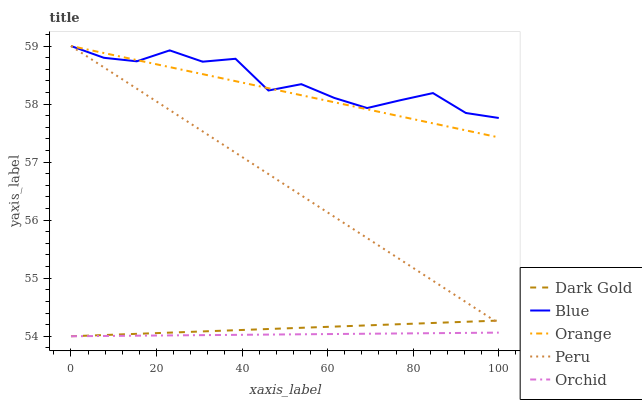Does Orchid have the minimum area under the curve?
Answer yes or no. Yes. Does Blue have the maximum area under the curve?
Answer yes or no. Yes. Does Orange have the minimum area under the curve?
Answer yes or no. No. Does Orange have the maximum area under the curve?
Answer yes or no. No. Is Peru the smoothest?
Answer yes or no. Yes. Is Blue the roughest?
Answer yes or no. Yes. Is Orange the smoothest?
Answer yes or no. No. Is Orange the roughest?
Answer yes or no. No. Does Orchid have the lowest value?
Answer yes or no. Yes. Does Orange have the lowest value?
Answer yes or no. No. Does Peru have the highest value?
Answer yes or no. Yes. Does Orchid have the highest value?
Answer yes or no. No. Is Orchid less than Peru?
Answer yes or no. Yes. Is Orange greater than Dark Gold?
Answer yes or no. Yes. Does Orange intersect Blue?
Answer yes or no. Yes. Is Orange less than Blue?
Answer yes or no. No. Is Orange greater than Blue?
Answer yes or no. No. Does Orchid intersect Peru?
Answer yes or no. No. 